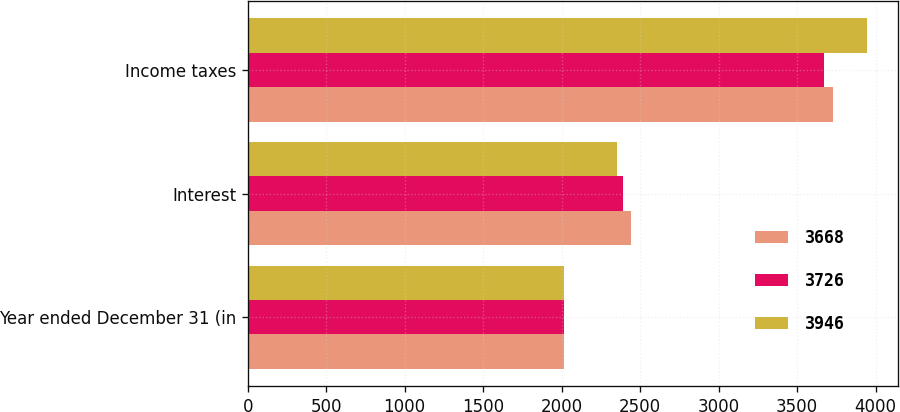Convert chart to OTSL. <chart><loc_0><loc_0><loc_500><loc_500><stacked_bar_chart><ecel><fcel>Year ended December 31 (in<fcel>Interest<fcel>Income taxes<nl><fcel>3668<fcel>2015<fcel>2443<fcel>3726<nl><fcel>3726<fcel>2014<fcel>2389<fcel>3668<nl><fcel>3946<fcel>2013<fcel>2355<fcel>3946<nl></chart> 